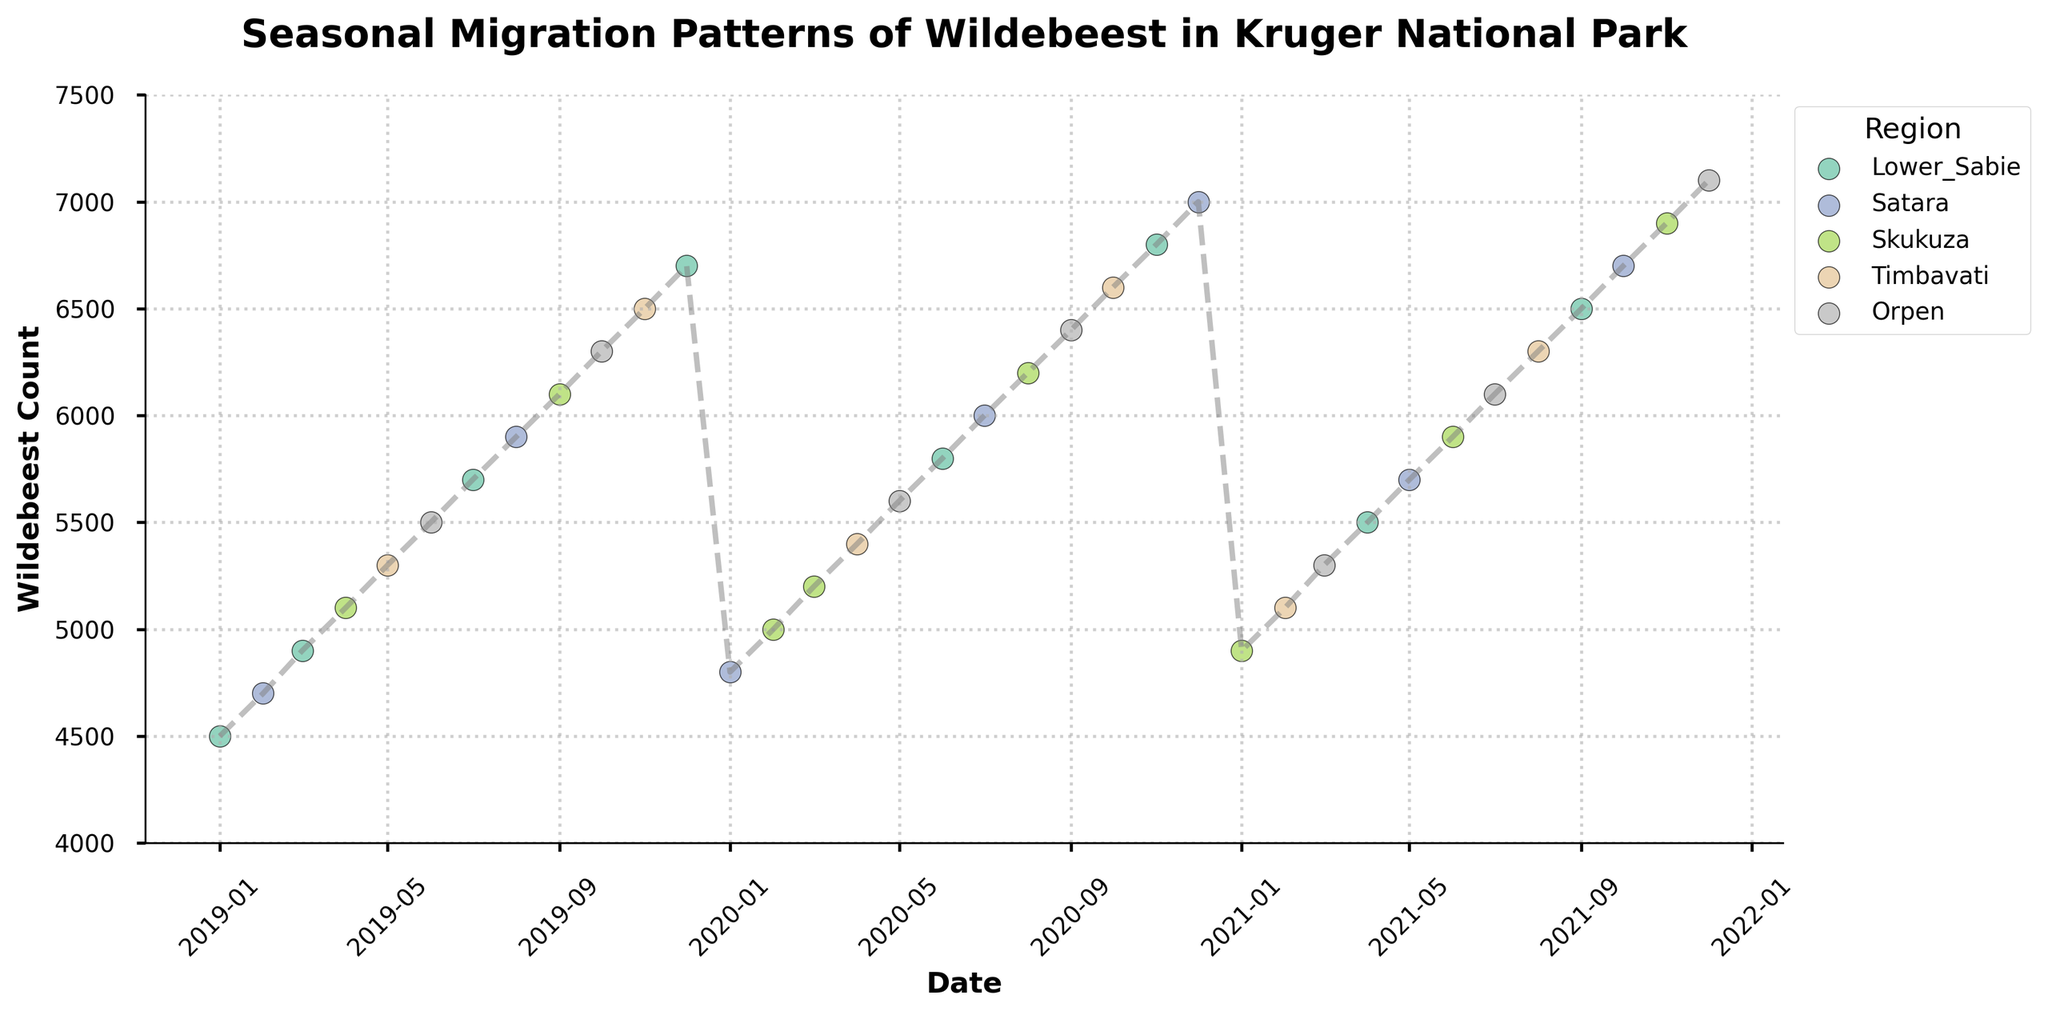What is the title of the figure? The title is typically at the top of the figure, often in bold and larger font size. Here, it is clearly visible as: "Seasonal Migration Patterns of Wildebeest in Kruger National Park".
Answer: Seasonal Migration Patterns of Wildebeest in Kruger National Park Which region has the highest wildebeest count in December 2020? To determine this, locate the data points for December 2020 and observe the marker for the corresponding region. December 2020 shows the highest data point at 7000 for Satara.
Answer: Satara What is the general trend of wildebeest counts from January 2019 to December 2021? By observing the overall direction of the plot line from January 2019 to December 2021, one can see if the counts are increasing, decreasing, or fluctuating. The trend appears to be an overall increase in wildebeest counts over the years.
Answer: Increasing Between which two consecutive months did the wildebeest count see the largest increase, and by how much? Compare the differences in wildebeest counts between each pair of consecutive months. The largest increase is observed between November 2020 (6800) and December 2020 (7000), which is 200.
Answer: November 2020 and December 2020; 200 Which region shows the most consistent pattern in wildebeest counts over the three years? By comparing the scatter points of each region over time, Timbavati appears to show relatively consistent increases without much fluctuation across the three years.
Answer: Timbavati How does the wildebeest count in January 2021 compare to January 2020? Locate the January data points for both years and compare their counts. January 2021 has a count of 4900, while January 2020 has a count of 4800, showing an increase.
Answer: Increased What is the average wildebeest count for the year 2019? Sum the monthly counts for 2019 and divide by 12. The total for 2019 is (4500 + 4700 + 4900 + 5100 + 5300 + 5500 + 5700 + 5900 + 6100 + 6300 + 6500 + 6700) = 67200, so the average is 67200 / 12 = 5600.
Answer: 5600 Which month shows the lowest wildebeest count in the entire dataset? Examine all the scatter points and identify the lowest point on the y-axis. The lowest count is 4500 in January 2019.
Answer: January 2019 In which region was the wildebeest count the highest in 2021? Investigate the scatter points labeled for the year 2021 across all regions. The highest count in 2021 is 7100, observed in Orpen.
Answer: Orpen What is the average wildebeest count for the region Skukuza across the three years? Sum the counts for Skukuza across all years and divide by the number of observations. Skukuza counts: 5100 + 5000 + 5200 + 4900 + 5900 + 6900 = 33000, divided by 6 gives 33000 / 6 = 5500.
Answer: 5500 